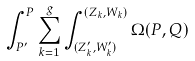<formula> <loc_0><loc_0><loc_500><loc_500>\int _ { P ^ { \prime } } ^ { P } \sum _ { k = 1 } ^ { g } \int _ { ( Z ^ { \prime } _ { k } , W ^ { \prime } _ { k } ) } ^ { ( Z _ { k } , W _ { k } ) } \Omega ( P , Q ) \,</formula> 